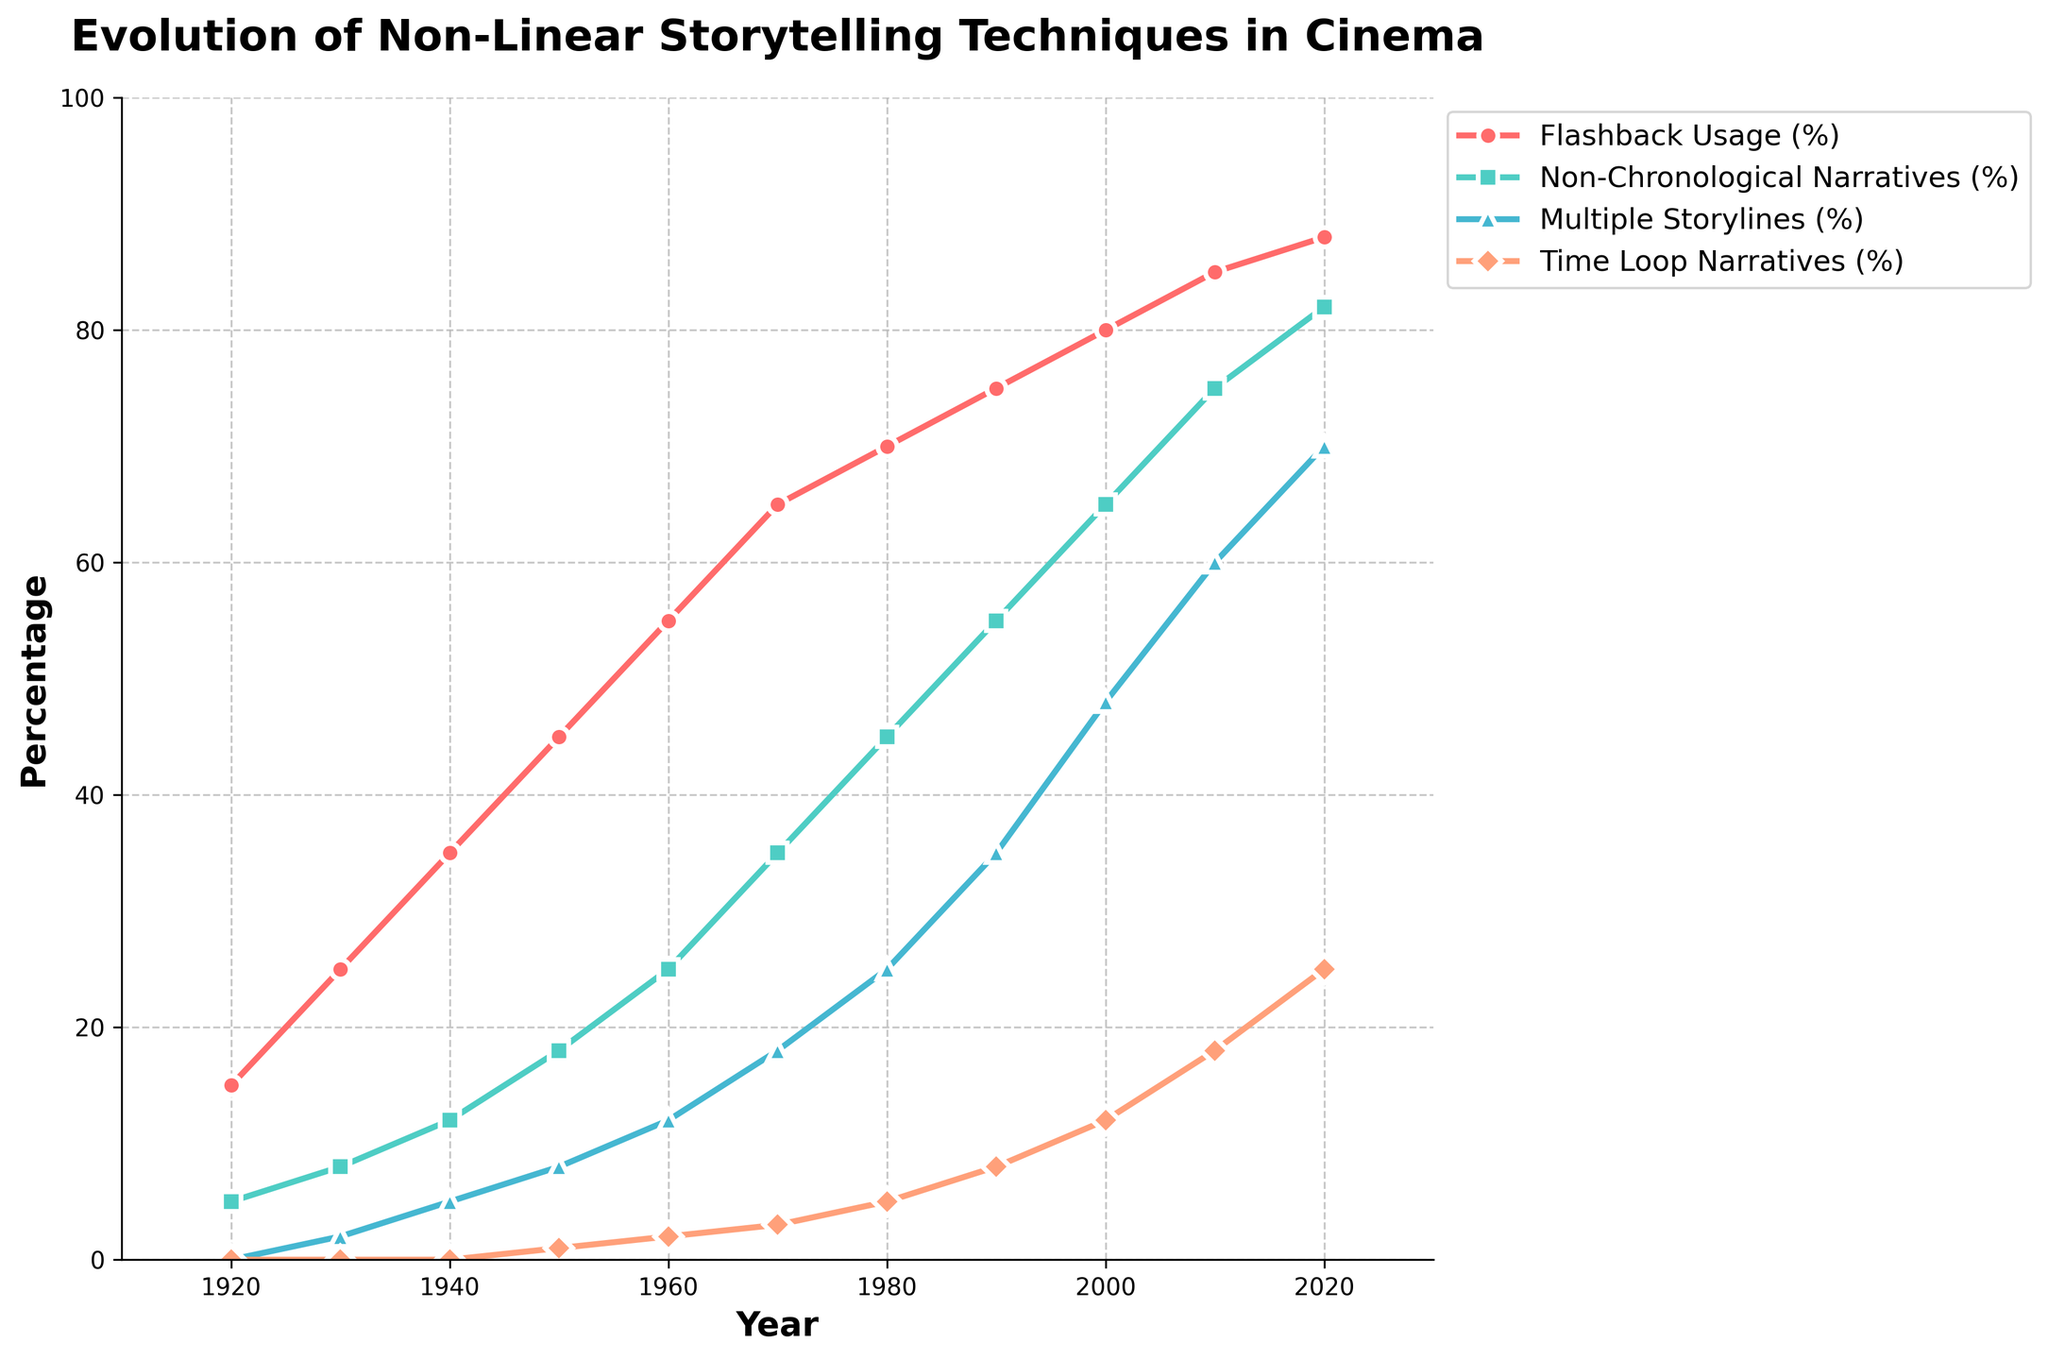What storytelling technique sees the most consistent increase in usage from 1920 to 2020? To determine which technique sees the most consistent increase, plot all the techniques and observe each trend line's slope and continuity. Flashback Usage (%) shows a smooth and consistent upward trend over the entire period.
Answer: Flashback Usage (%) By how much did the percentage of Multiple Storylines increase from 1960 to 2020? In 1960, the percentage of Multiple Storylines was 12%, and in 2020 it was 70%. The increase is calculated as 70% - 12% = 58%.
Answer: 58% Which two storytelling techniques had equal usage percentages for the first time, and in which year? To identify the year and techniques with equal percentages, visually inspect the plot to find intersecting data points. In 1960, Non-Chronological Narratives (%) and Multiple Storylines (%) both had 25%.
Answer: Non-Chronological Narratives (%) and Multiple Storylines (%) in 1960 What is the overall trend of Time Loop Narratives (%) from 1920 to 2020? Observe how Time Loop Narratives (%) has changed over time by following its line plot. The technique shows an upward trend starting from 0% in 1920, climbing gradually to 25% by 2020.
Answer: Increasing Which year saw the highest release of non-linear films? Look at the line chart showing the number of non-linear films released and find the highest point. The year is 2020, with 500 films released.
Answer: 2020 Did Flashback Usage (%) ever decrease within the century, according to the plot? Track the line representing Flashback Usage (%) to confirm if there is any downward slope at any point. The plot shows a consistent increase without any decrease.
Answer: No What is the difference in the usage percentage between the year with the highest and lowest Multiple Storylines (%)? Find the highest and lowest data points for Multiple Storylines (%) in the plot. The highest is 70% in 2020, and the lowest is 0% in 1920. The difference is 70% - 0% = 70%.
Answer: 70% How many more non-linear films were released in 2020 compared to 2000? From the plot, in 2020, 500 films were released, and in 2000, 200 films were released. The difference is 500 - 200 = 300 films.
Answer: 300 Which storytelling technique surpassed a 50% usage rate first and in which year? Inspect each line plot to identify the first technique to cross the 50% mark and the corresponding year. The Flashback Usage (%) crossed 50% first in 1960.
Answer: Flashback Usage (%) in 1960 